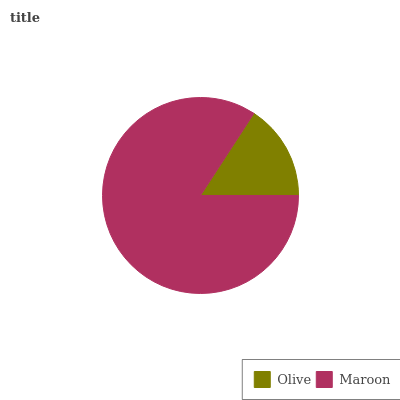Is Olive the minimum?
Answer yes or no. Yes. Is Maroon the maximum?
Answer yes or no. Yes. Is Maroon the minimum?
Answer yes or no. No. Is Maroon greater than Olive?
Answer yes or no. Yes. Is Olive less than Maroon?
Answer yes or no. Yes. Is Olive greater than Maroon?
Answer yes or no. No. Is Maroon less than Olive?
Answer yes or no. No. Is Maroon the high median?
Answer yes or no. Yes. Is Olive the low median?
Answer yes or no. Yes. Is Olive the high median?
Answer yes or no. No. Is Maroon the low median?
Answer yes or no. No. 